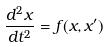Convert formula to latex. <formula><loc_0><loc_0><loc_500><loc_500>\frac { d ^ { 2 } x } { d t ^ { 2 } } = f ( x , x ^ { \prime } )</formula> 